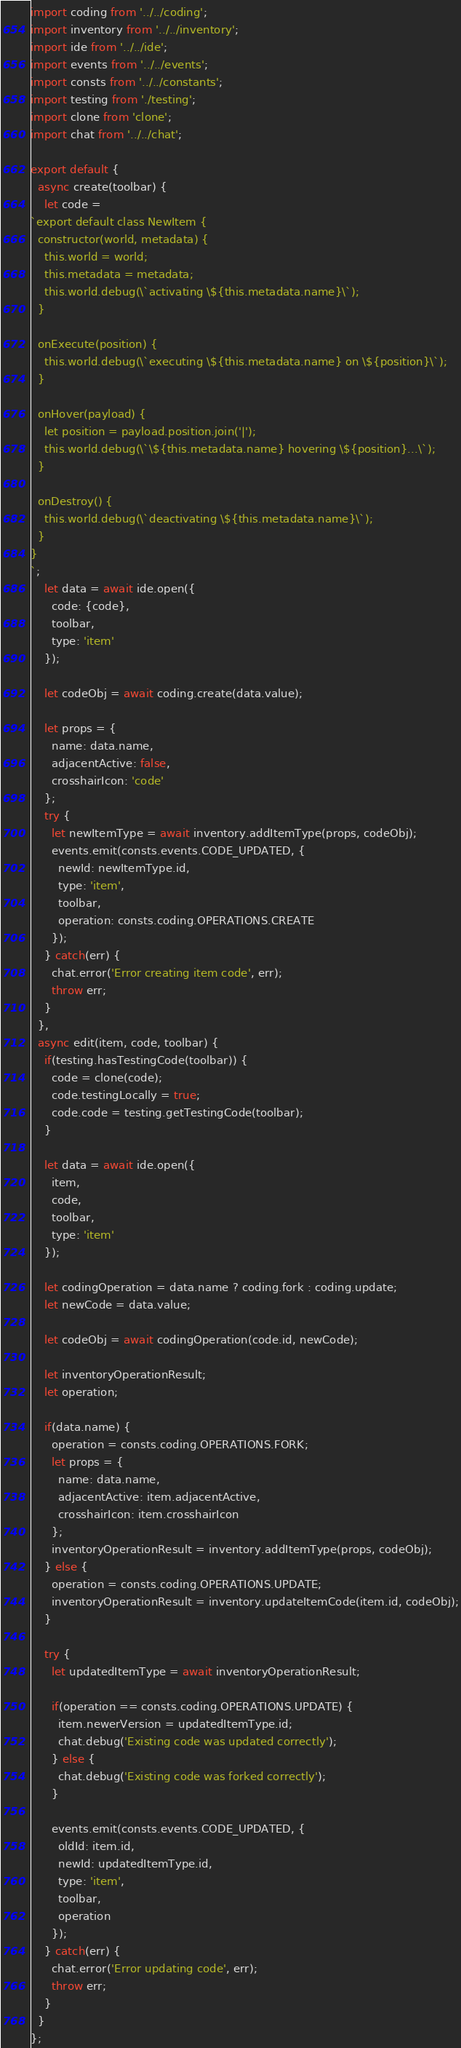<code> <loc_0><loc_0><loc_500><loc_500><_JavaScript_>import coding from '../../coding';
import inventory from '../../inventory';
import ide from '../../ide';
import events from '../../events';
import consts from '../../constants';
import testing from './testing';
import clone from 'clone';
import chat from '../../chat';

export default {
  async create(toolbar) {
    let code =
`export default class NewItem {
  constructor(world, metadata) {
    this.world = world;
    this.metadata = metadata;
    this.world.debug(\`activating \${this.metadata.name}\`);
  }

  onExecute(position) {
    this.world.debug(\`executing \${this.metadata.name} on \${position}\`);
  }

  onHover(payload) {
    let position = payload.position.join('|');
    this.world.debug(\`\${this.metadata.name} hovering \${position}...\`);
  }

  onDestroy() {
    this.world.debug(\`deactivating \${this.metadata.name}\`);
  }
}
`;
    let data = await ide.open({
      code: {code},
      toolbar,
      type: 'item'
    });

    let codeObj = await coding.create(data.value);

    let props = {
      name: data.name,
      adjacentActive: false,
      crosshairIcon: 'code'
    };
    try {
      let newItemType = await inventory.addItemType(props, codeObj);
      events.emit(consts.events.CODE_UPDATED, {
        newId: newItemType.id,
        type: 'item',
        toolbar,
        operation: consts.coding.OPERATIONS.CREATE
      });
    } catch(err) {
      chat.error('Error creating item code', err);
      throw err;
    }
  },
  async edit(item, code, toolbar) {
    if(testing.hasTestingCode(toolbar)) {
      code = clone(code);
      code.testingLocally = true;
      code.code = testing.getTestingCode(toolbar);
    }

    let data = await ide.open({
      item,
      code,
      toolbar,
      type: 'item'
    });

    let codingOperation = data.name ? coding.fork : coding.update;
    let newCode = data.value;

    let codeObj = await codingOperation(code.id, newCode);

    let inventoryOperationResult;
    let operation;

    if(data.name) {
      operation = consts.coding.OPERATIONS.FORK;
      let props = {
        name: data.name,
        adjacentActive: item.adjacentActive,
        crosshairIcon: item.crosshairIcon
      };
      inventoryOperationResult = inventory.addItemType(props, codeObj);
    } else {
      operation = consts.coding.OPERATIONS.UPDATE;
      inventoryOperationResult = inventory.updateItemCode(item.id, codeObj);
    }

    try {
      let updatedItemType = await inventoryOperationResult;

      if(operation == consts.coding.OPERATIONS.UPDATE) {
        item.newerVersion = updatedItemType.id;
        chat.debug('Existing code was updated correctly');
      } else {
        chat.debug('Existing code was forked correctly');
      }

      events.emit(consts.events.CODE_UPDATED, {
        oldId: item.id,
        newId: updatedItemType.id,
        type: 'item',
        toolbar,
        operation
      });
    } catch(err) {
      chat.error('Error updating code', err);
      throw err;
    }
  }
};
</code> 